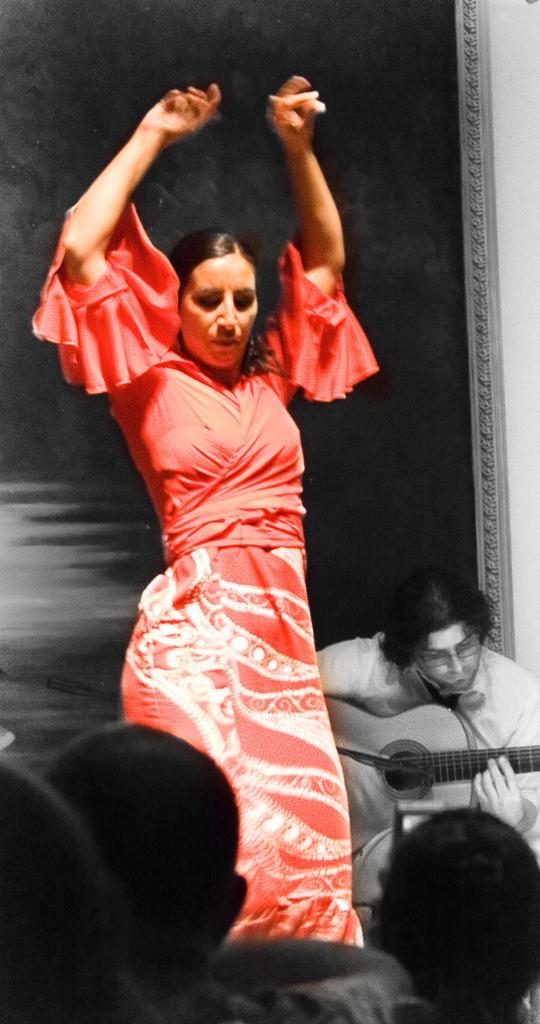Could you give a brief overview of what you see in this image? This is a picture of a woman in red dress was dancing on a floor. In front of the women there are other persons. behind the woman there is a man who is sitting and playing guitar. 